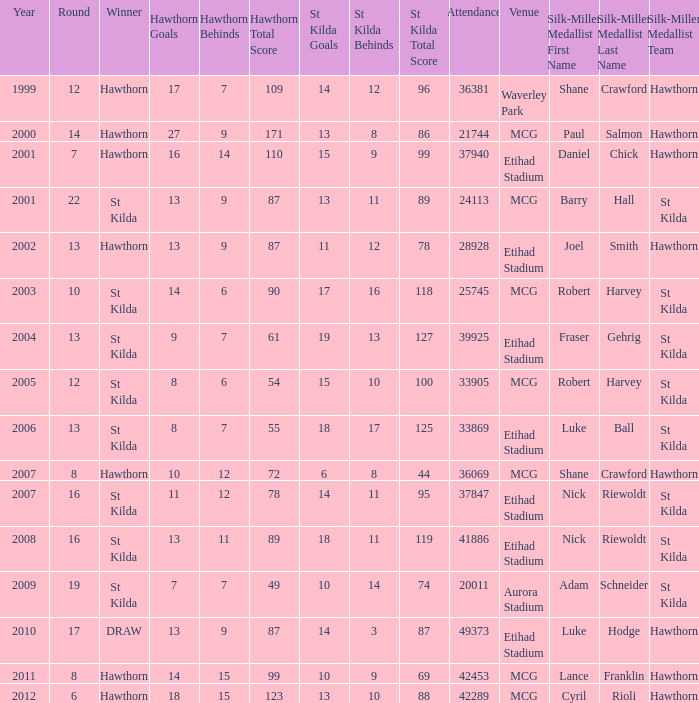What the listed in round when the hawthorn score is 17.7.109? 12.0. 